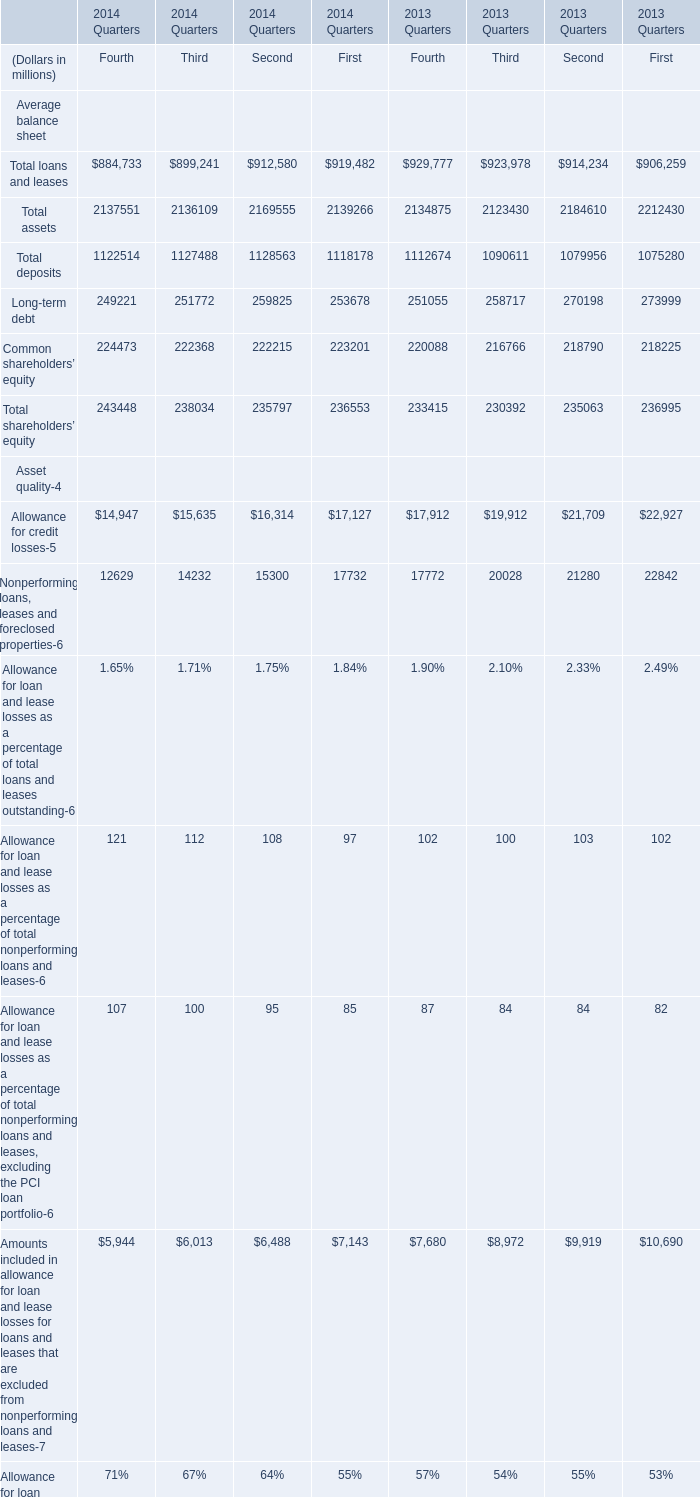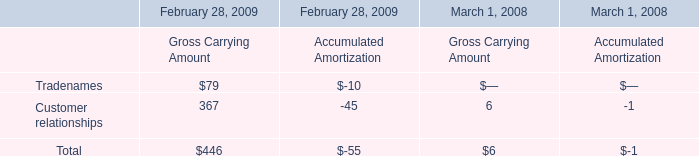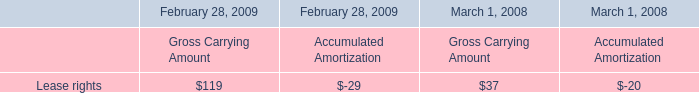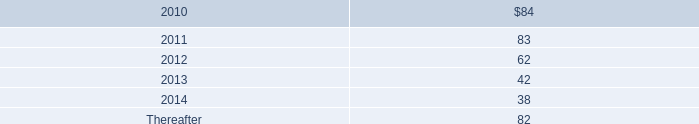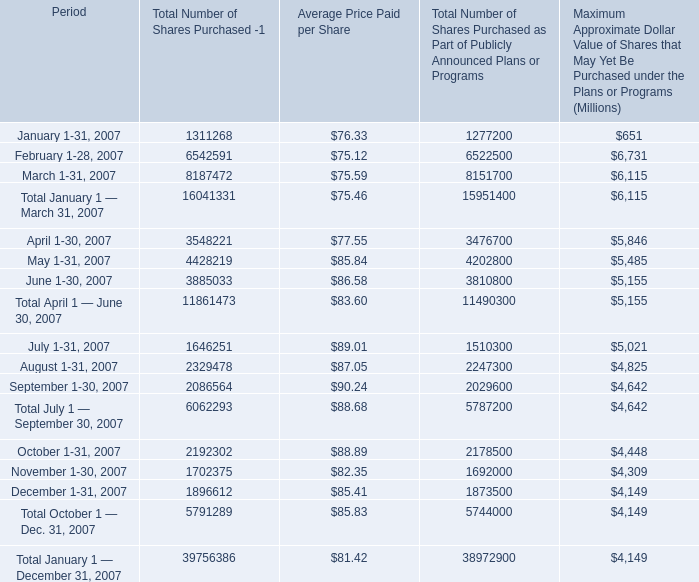What is the sum of Tier 1 capital of Fourth in 2014 and Customer relationships of Gross Carrying Amount in 2009? (in million) 
Computations: (13.4 + 367)
Answer: 380.4. 